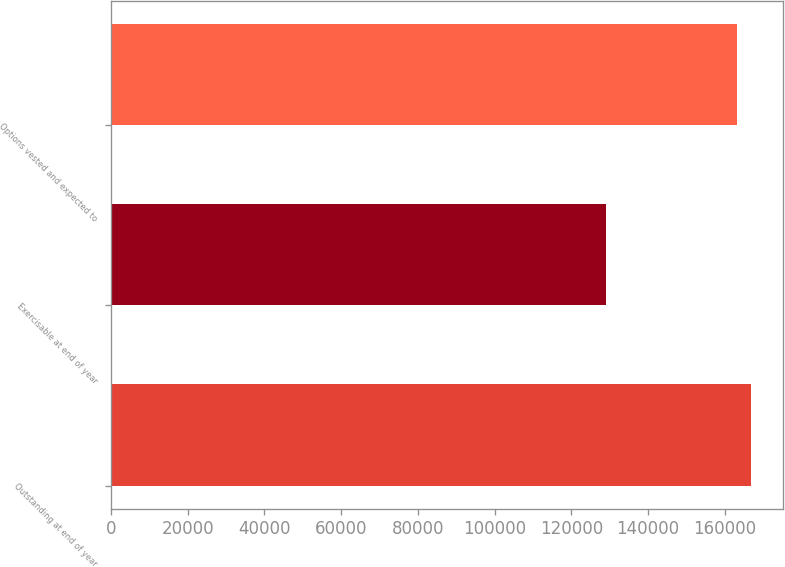Convert chart to OTSL. <chart><loc_0><loc_0><loc_500><loc_500><bar_chart><fcel>Outstanding at end of year<fcel>Exercisable at end of year<fcel>Options vested and expected to<nl><fcel>166930<fcel>129040<fcel>163162<nl></chart> 